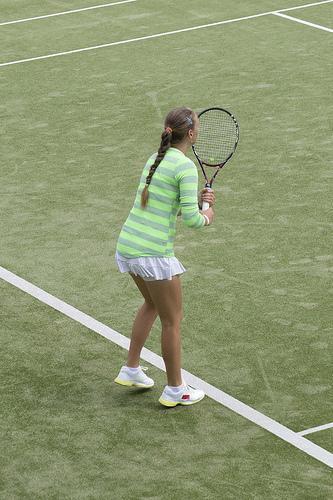How many people are playing tennis in the picture?
Give a very brief answer. 1. How many dinosaurs are in the picture?
Give a very brief answer. 0. 